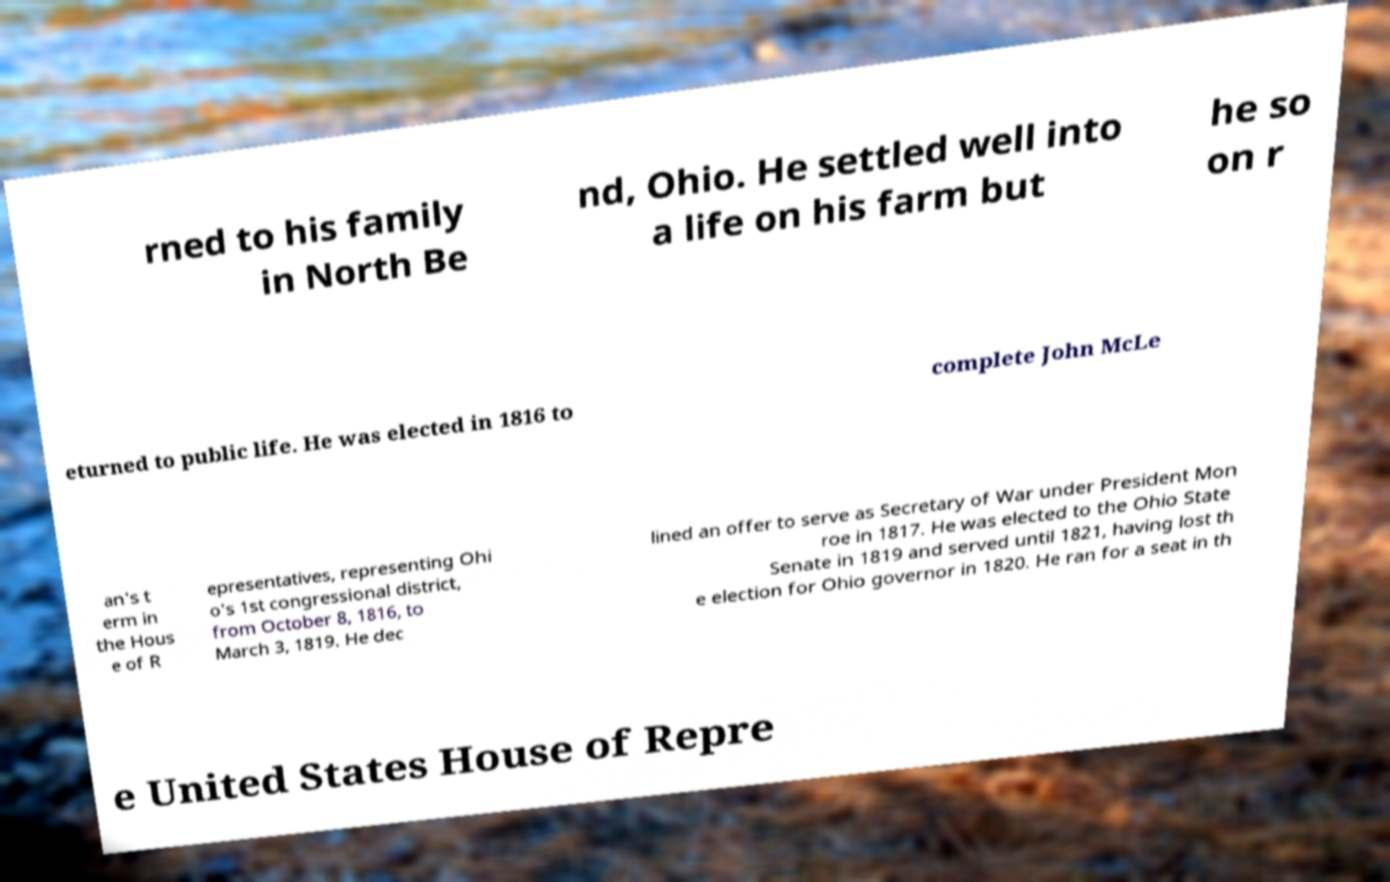There's text embedded in this image that I need extracted. Can you transcribe it verbatim? rned to his family in North Be nd, Ohio. He settled well into a life on his farm but he so on r eturned to public life. He was elected in 1816 to complete John McLe an's t erm in the Hous e of R epresentatives, representing Ohi o's 1st congressional district, from October 8, 1816, to March 3, 1819. He dec lined an offer to serve as Secretary of War under President Mon roe in 1817. He was elected to the Ohio State Senate in 1819 and served until 1821, having lost th e election for Ohio governor in 1820. He ran for a seat in th e United States House of Repre 